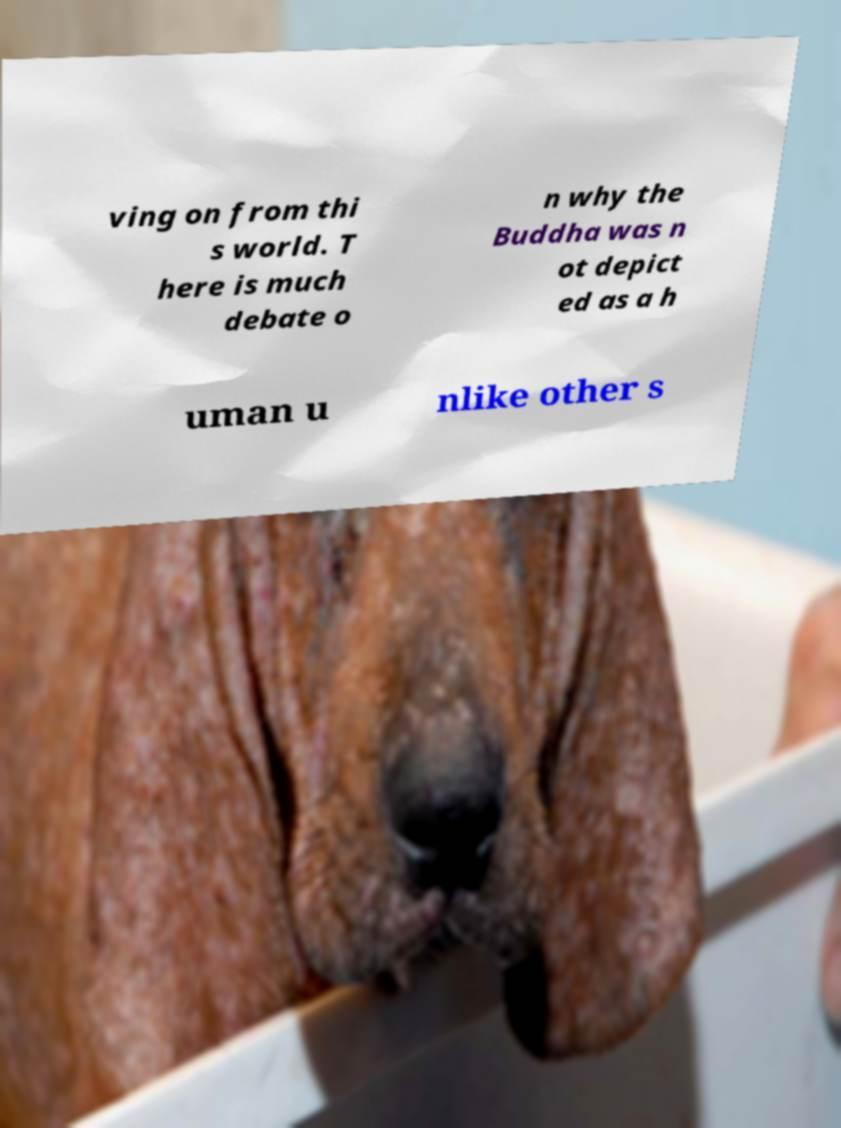Can you accurately transcribe the text from the provided image for me? ving on from thi s world. T here is much debate o n why the Buddha was n ot depict ed as a h uman u nlike other s 